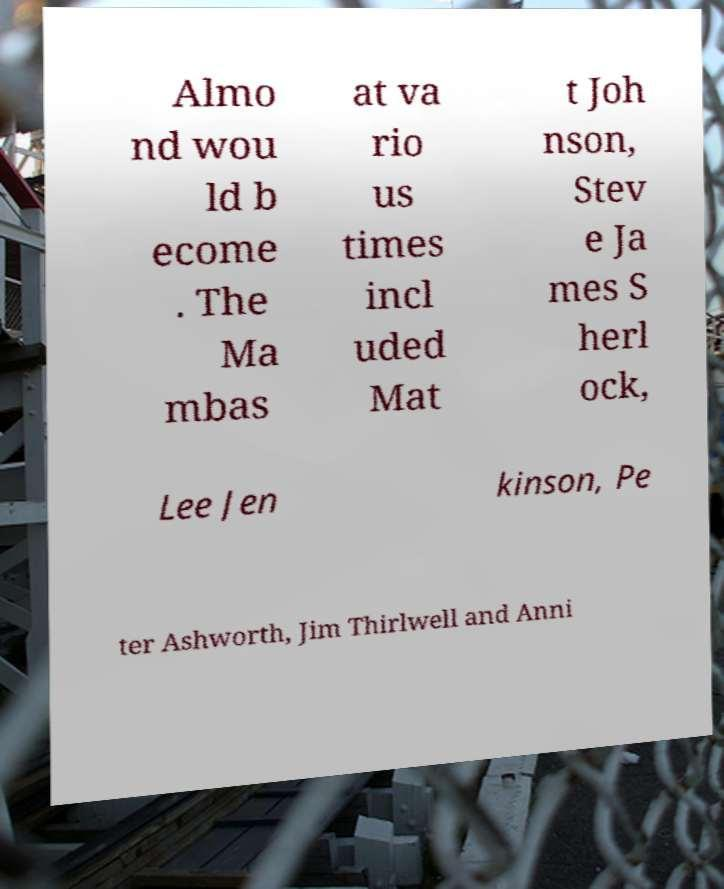For documentation purposes, I need the text within this image transcribed. Could you provide that? Almo nd wou ld b ecome . The Ma mbas at va rio us times incl uded Mat t Joh nson, Stev e Ja mes S herl ock, Lee Jen kinson, Pe ter Ashworth, Jim Thirlwell and Anni 